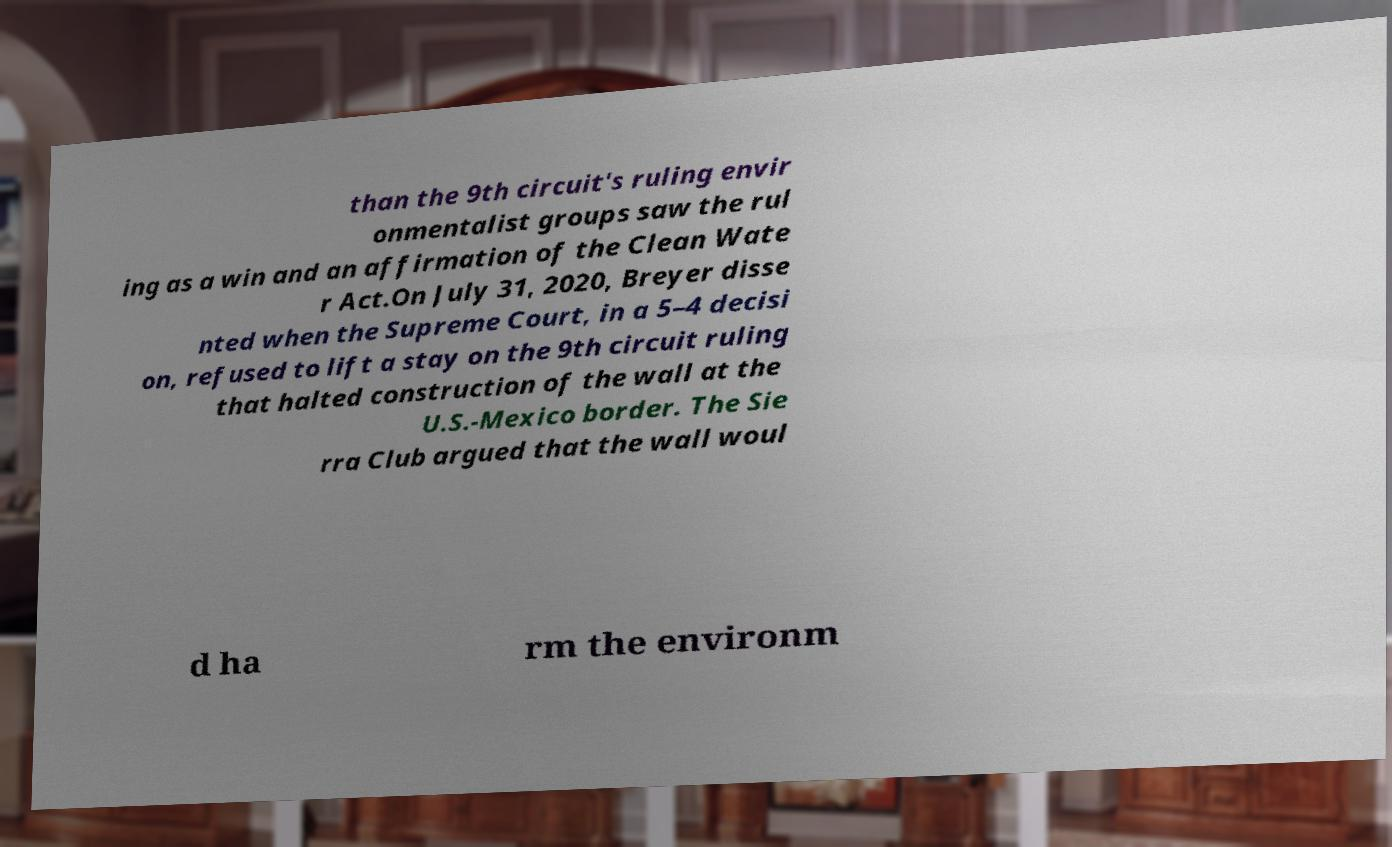Could you assist in decoding the text presented in this image and type it out clearly? than the 9th circuit's ruling envir onmentalist groups saw the rul ing as a win and an affirmation of the Clean Wate r Act.On July 31, 2020, Breyer disse nted when the Supreme Court, in a 5–4 decisi on, refused to lift a stay on the 9th circuit ruling that halted construction of the wall at the U.S.-Mexico border. The Sie rra Club argued that the wall woul d ha rm the environm 